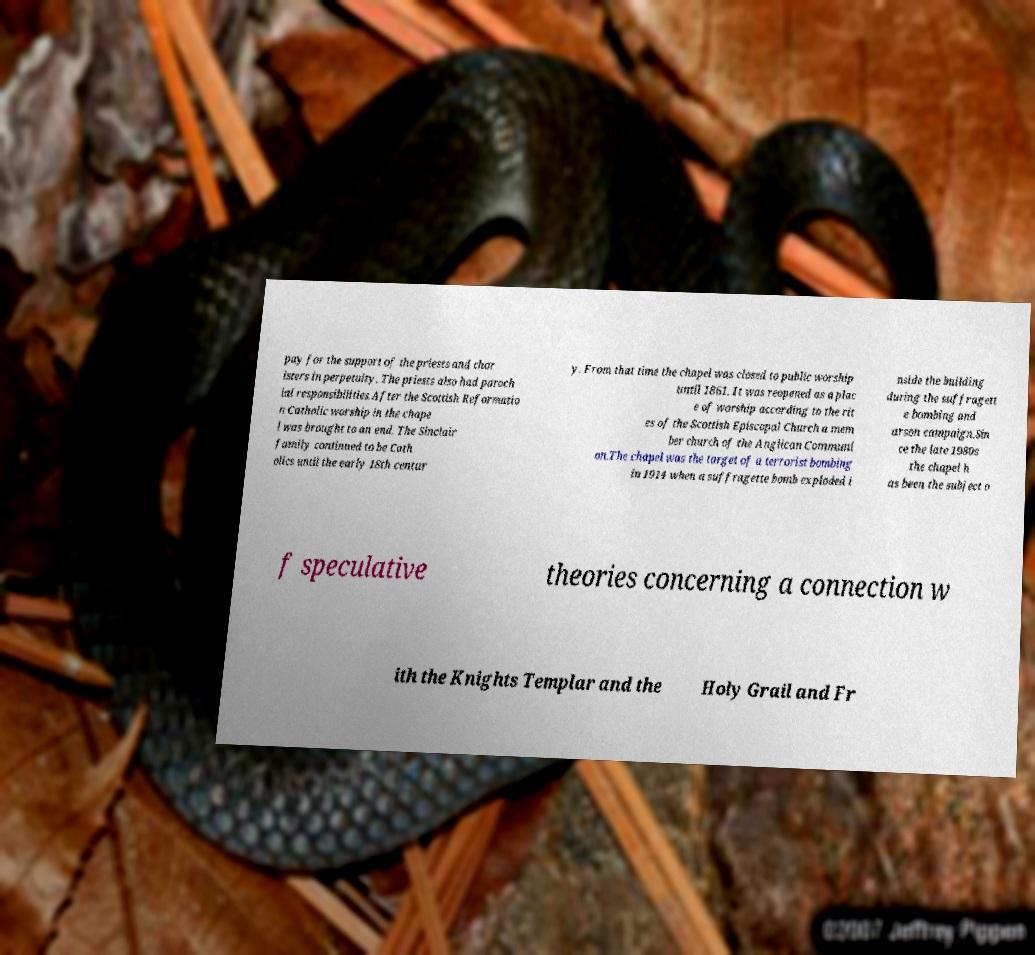There's text embedded in this image that I need extracted. Can you transcribe it verbatim? pay for the support of the priests and chor isters in perpetuity. The priests also had paroch ial responsibilities.After the Scottish Reformatio n Catholic worship in the chape l was brought to an end. The Sinclair family continued to be Cath olics until the early 18th centur y. From that time the chapel was closed to public worship until 1861. It was reopened as a plac e of worship according to the rit es of the Scottish Episcopal Church a mem ber church of the Anglican Communi on.The chapel was the target of a terrorist bombing in 1914 when a suffragette bomb exploded i nside the building during the suffragett e bombing and arson campaign.Sin ce the late 1980s the chapel h as been the subject o f speculative theories concerning a connection w ith the Knights Templar and the Holy Grail and Fr 